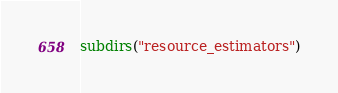<code> <loc_0><loc_0><loc_500><loc_500><_CMake_>subdirs("resource_estimators")
</code> 